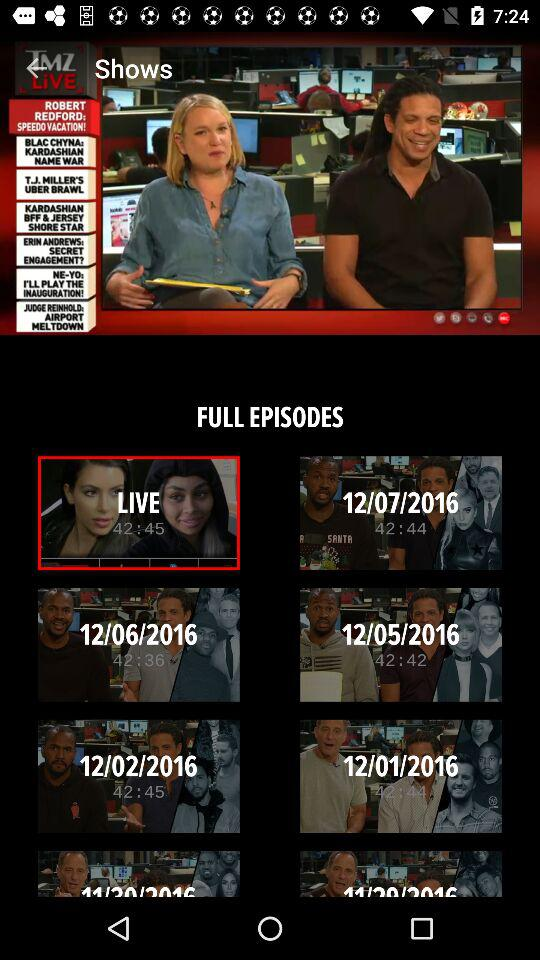What is the application name? The application name is "TMZ LIVE". 